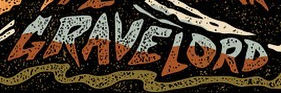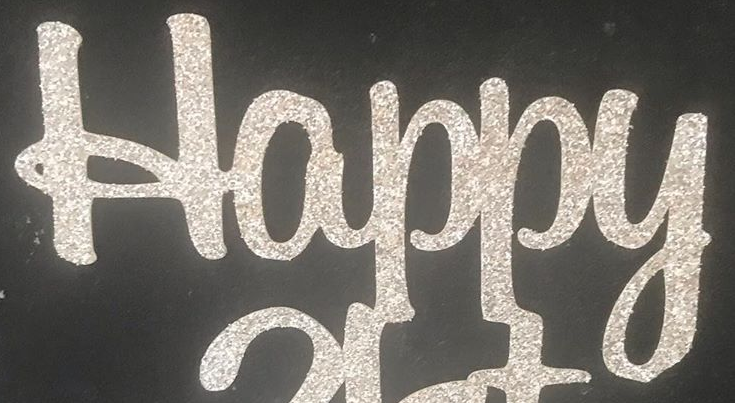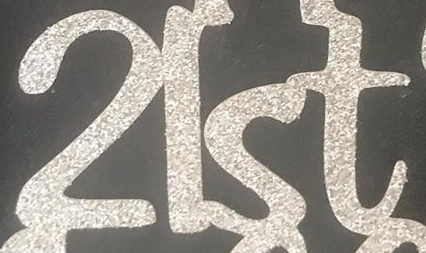Identify the words shown in these images in order, separated by a semicolon. GRAVELORD; Happy; 2lst 